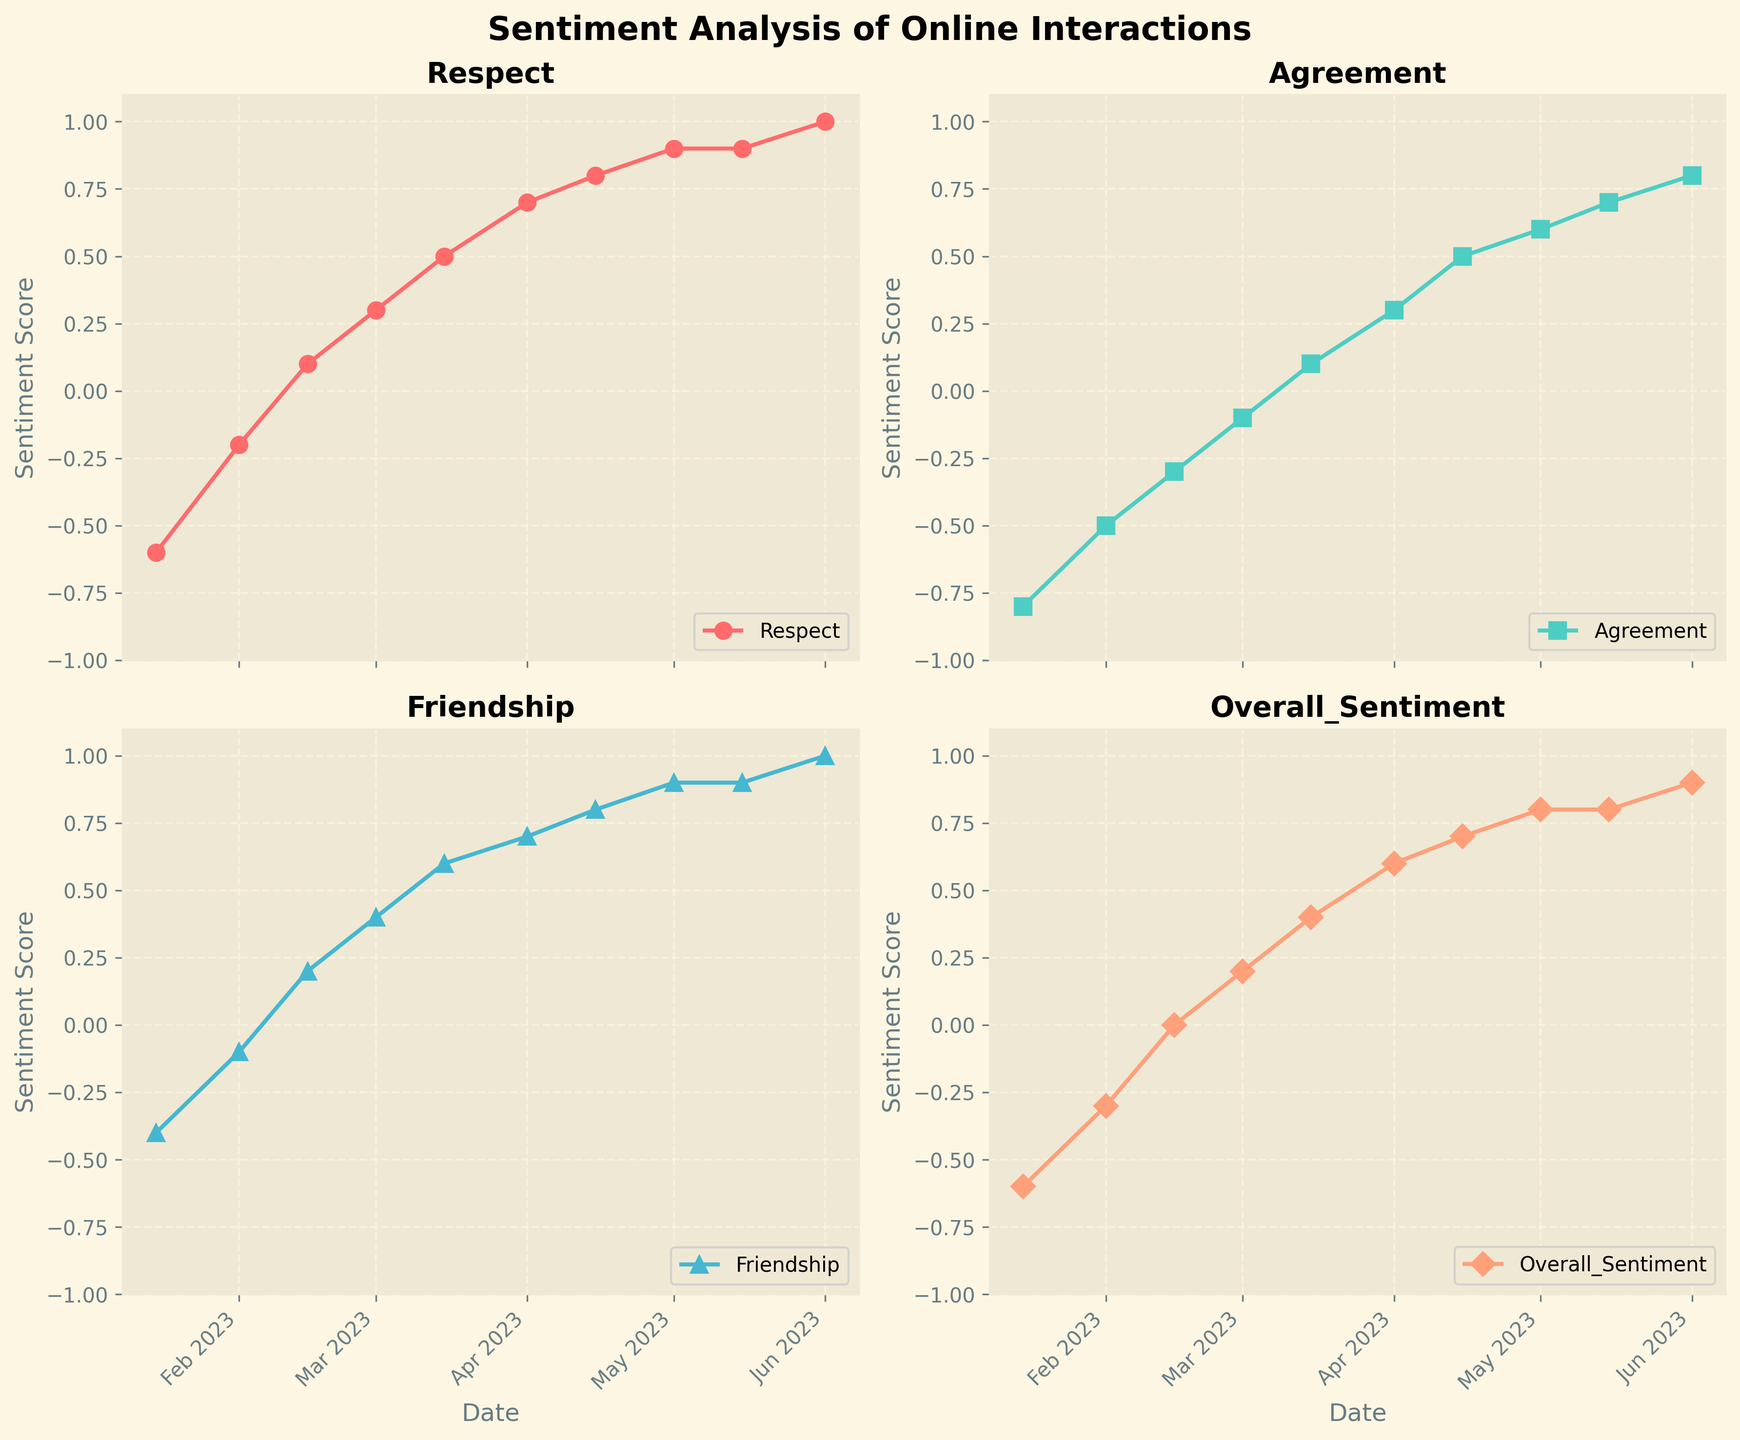What's the overall trend seen in the 'Respect' subplot? The 'Respect' subplot shows a consistent upward trend from -0.6 in January to 1.0 in June, indicating a continuous increase in respect over time.
Answer: Upward trend Which subplot has the highest final sentiment score? The subplot 'Respect' ends at 1.0, which is higher than the other subplots' final scores: 'Agreement' at 0.8, 'Friendship' at 1.0, and 'Overall_Sentiment' at 0.9. However, both 'Respect' and 'Friendship' end at 1.0, making them tie for the highest final score.
Answer: Respect and Friendship On which date does the 'Overall_Sentiment' subplot show a neutral score (0)? The 'Overall_Sentiment' subplot shows a neutral score on February 15th.
Answer: February 15 How many points are plotted in each subplot? Each subplot has one data point for each label on the x-axis, and there are ten dates listed from January 15 to June 1, hence ten points in each subplot.
Answer: Ten points Which sentiment category shows the earliest shift from negative to positive? Viewing each subplot, 'Respect' transitions from a negative to a positive score the earliest on February 15.
Answer: Respect on February 15 Compare the sentiment scores for 'Agreement' and 'Friendship' on March 15. Which is higher? The 'Agreement' subplot shows a score of 0.1, while the 'Friendship' subplot shows a score of 0.6 on March 15. Therefore, 'Friendship' is higher.
Answer: Friendship What is the average sentiment score for 'Overall_Sentiment' over the period shown? The 'Overall_Sentiment' scores are -0.6, -0.3, 0, 0.2, 0.4, 0.6, 0.7, 0.8, 0.8, and 0.9. Add these values and divide by 10. Sum is (4.5 / 10 = 0.45) so the average is 0.45.
Answer: 0.45 Between which two consecutive dates does the 'Respect' subplot see the largest increase? 'Respect' sees the largest increase between April 15 and May 1, where it jumps from 0.8 to 0.9.
Answer: April 15 to May 1 